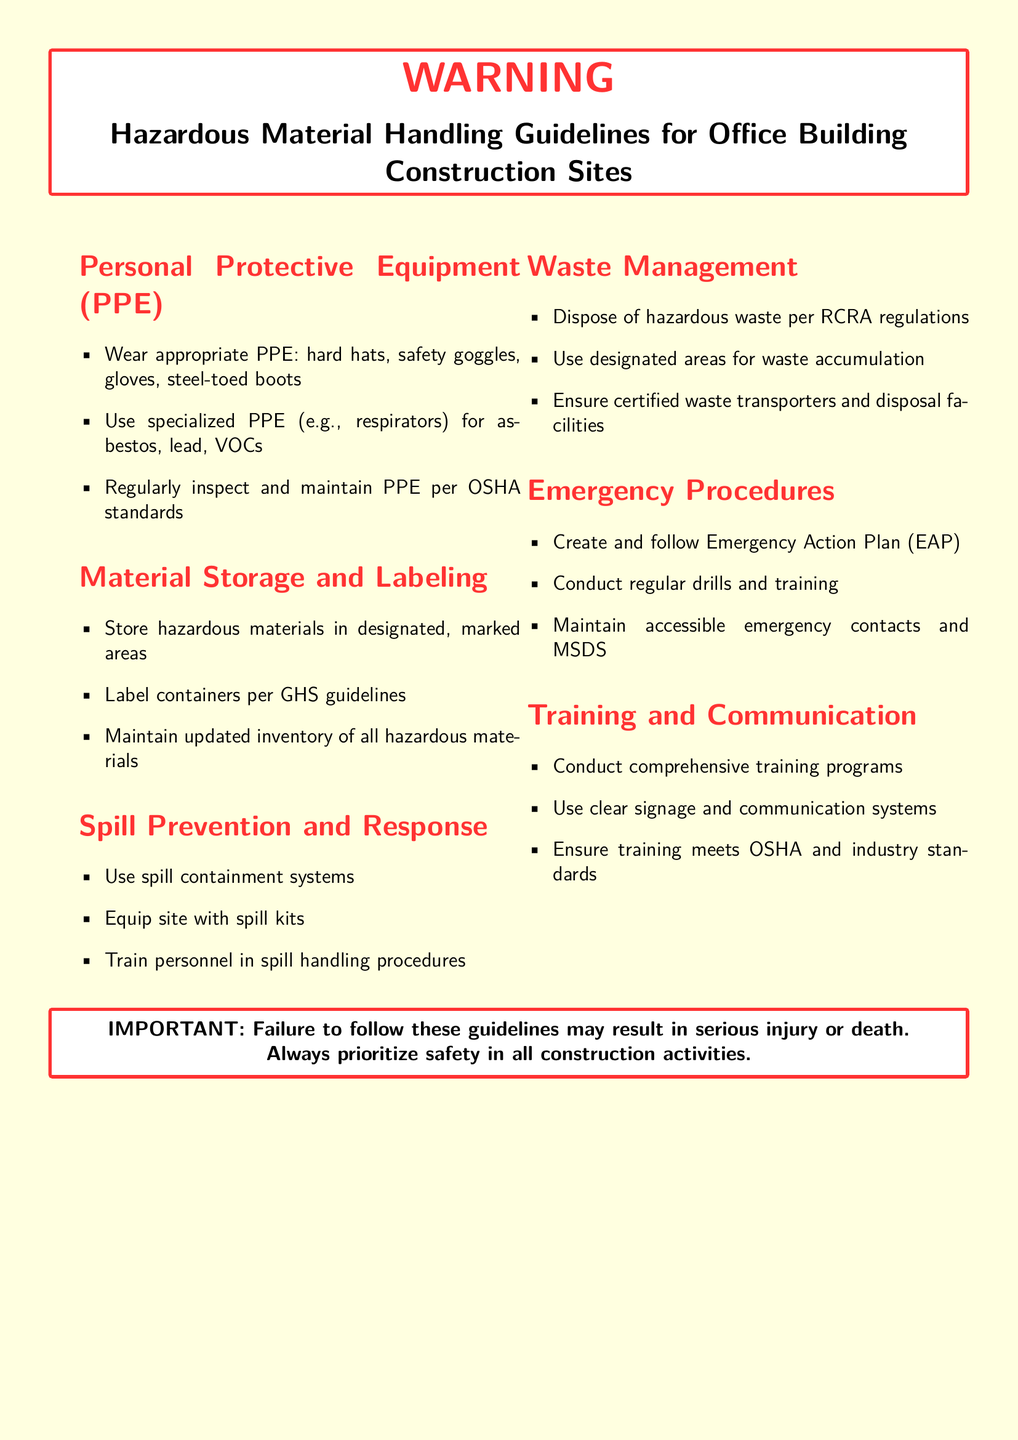What should be worn for PPE? The document states that appropriate PPE includes hard hats, safety goggles, gloves, and steel-toed boots.
Answer: hard hats, safety goggles, gloves, steel-toed boots What labeling guidelines must be followed? Containers must be labeled per GHS guidelines according to the document.
Answer: GHS guidelines What should be included in the Emergency Action Plan? The document emphasizes the need to follow a created Emergency Action Plan that includes regular drills and training.
Answer: Emergency Action Plan What materials should be used for spill containment? The guidelines recommend using spill containment systems for spill prevention.
Answer: spill containment systems How often should PPE be inspected? The document mentions that PPE should be regularly inspected and maintained per OSHA standards.
Answer: regularly What is an important aspect of waste management? The document advises that hazardous waste must be disposed of per RCRA regulations as part of waste management.
Answer: RCRA regulations What should be maintained alongside emergency contacts? The document states that Material Safety Data Sheets (MSDS) should be maintained alongside emergency contacts.
Answer: MSDS What is the consequence of not following the guidelines? The document specifies that failure to follow these guidelines may result in serious injury or death.
Answer: serious injury or death 